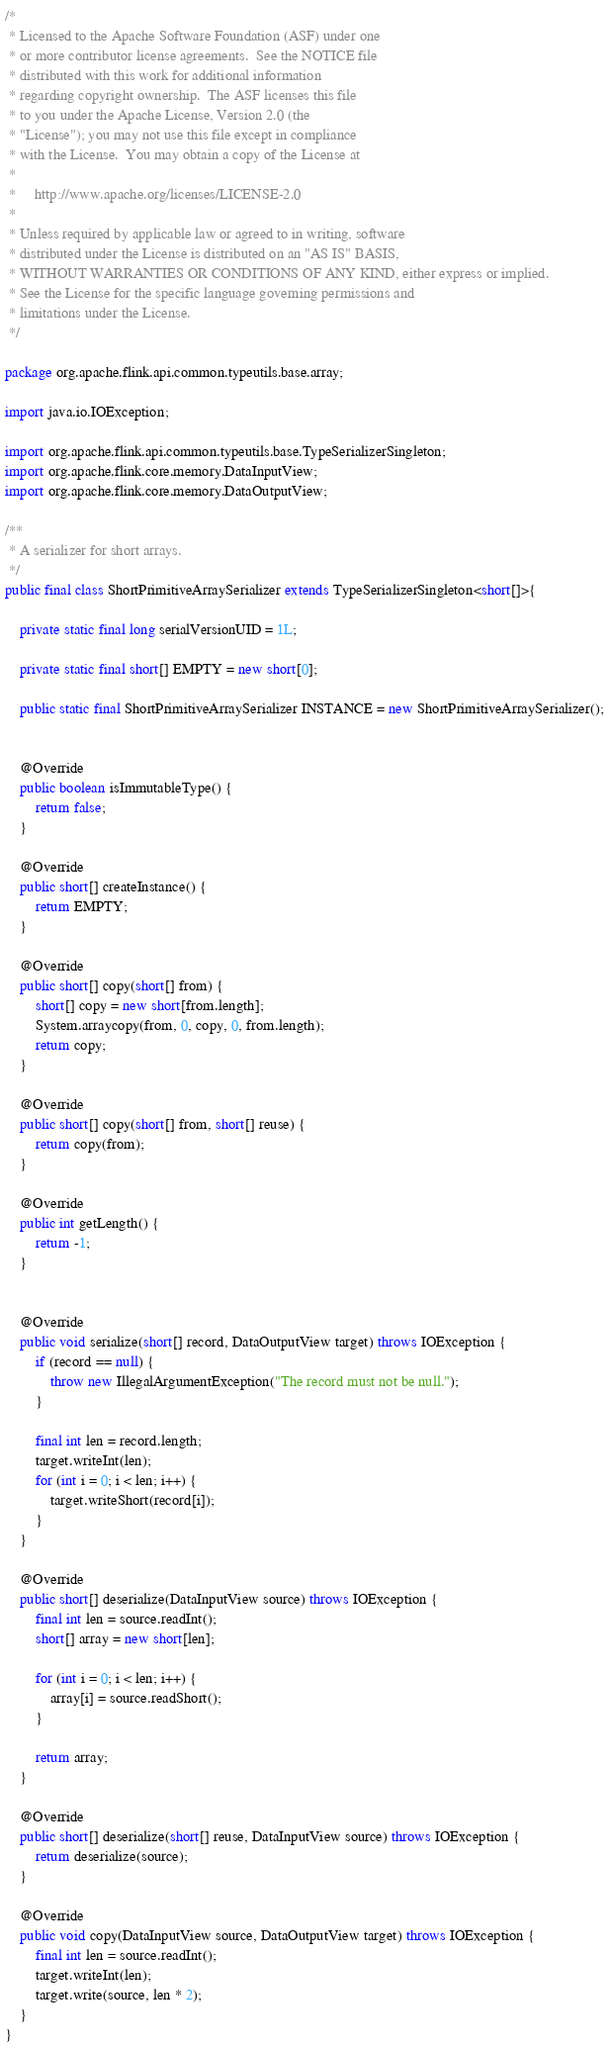<code> <loc_0><loc_0><loc_500><loc_500><_Java_>/*
 * Licensed to the Apache Software Foundation (ASF) under one
 * or more contributor license agreements.  See the NOTICE file
 * distributed with this work for additional information
 * regarding copyright ownership.  The ASF licenses this file
 * to you under the Apache License, Version 2.0 (the
 * "License"); you may not use this file except in compliance
 * with the License.  You may obtain a copy of the License at
 *
 *     http://www.apache.org/licenses/LICENSE-2.0
 *
 * Unless required by applicable law or agreed to in writing, software
 * distributed under the License is distributed on an "AS IS" BASIS,
 * WITHOUT WARRANTIES OR CONDITIONS OF ANY KIND, either express or implied.
 * See the License for the specific language governing permissions and
 * limitations under the License.
 */

package org.apache.flink.api.common.typeutils.base.array;

import java.io.IOException;

import org.apache.flink.api.common.typeutils.base.TypeSerializerSingleton;
import org.apache.flink.core.memory.DataInputView;
import org.apache.flink.core.memory.DataOutputView;

/**
 * A serializer for short arrays.
 */
public final class ShortPrimitiveArraySerializer extends TypeSerializerSingleton<short[]>{

	private static final long serialVersionUID = 1L;
	
	private static final short[] EMPTY = new short[0];

	public static final ShortPrimitiveArraySerializer INSTANCE = new ShortPrimitiveArraySerializer();
	
	
	@Override
	public boolean isImmutableType() {
		return false;
	}
	
	@Override
	public short[] createInstance() {
		return EMPTY;
	}

	@Override
	public short[] copy(short[] from) {
		short[] copy = new short[from.length];
		System.arraycopy(from, 0, copy, 0, from.length);
		return copy;
	}
	
	@Override
	public short[] copy(short[] from, short[] reuse) {
		return copy(from);
	}

	@Override
	public int getLength() {
		return -1;
	}


	@Override
	public void serialize(short[] record, DataOutputView target) throws IOException {
		if (record == null) {
			throw new IllegalArgumentException("The record must not be null.");
		}
		
		final int len = record.length;
		target.writeInt(len);
		for (int i = 0; i < len; i++) {
			target.writeShort(record[i]);
		}
	}

	@Override
	public short[] deserialize(DataInputView source) throws IOException {
		final int len = source.readInt();
		short[] array = new short[len];
		
		for (int i = 0; i < len; i++) {
			array[i] = source.readShort();
		}
		
		return array;
	}

	@Override
	public short[] deserialize(short[] reuse, DataInputView source) throws IOException {
		return deserialize(source);
	}

	@Override
	public void copy(DataInputView source, DataOutputView target) throws IOException {
		final int len = source.readInt();
		target.writeInt(len);
		target.write(source, len * 2);
	}
}
</code> 